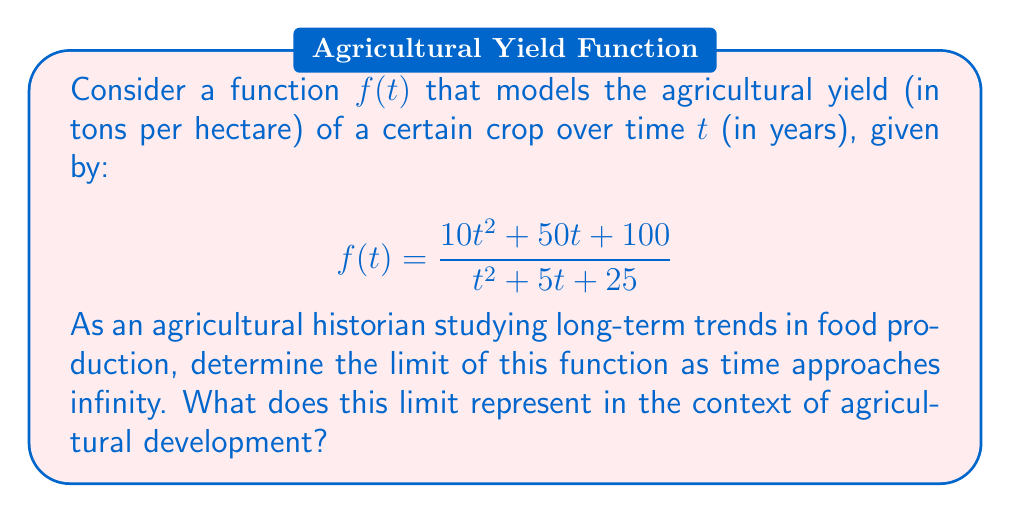Can you solve this math problem? To solve this problem, we'll follow these steps:

1) To find the limit as $t$ approaches infinity, we need to look at the behavior of the numerator and denominator separately as $t$ gets very large.

2) Both the numerator and denominator are quadratic functions. When $t$ is very large, the $t^2$ term will dominate in both.

3) We can factor out $t^2$ from both the numerator and denominator:

   $$\lim_{t \to \infty} f(t) = \lim_{t \to \infty} \frac{t^2(10 + \frac{50}{t} + \frac{100}{t^2})}{t^2(1 + \frac{5}{t} + \frac{25}{t^2})}$$

4) As $t$ approaches infinity, $\frac{1}{t}$ and $\frac{1}{t^2}$ approach 0, so:

   $$\lim_{t \to \infty} f(t) = \lim_{t \to \infty} \frac{t^2(10 + 0 + 0)}{t^2(1 + 0 + 0)} = \frac{10t^2}{t^2} = 10$$

5) Therefore, the limit of the function as $t$ approaches infinity is 10.

In the context of agricultural development, this limit represents the maximum theoretical yield (in tons per hectare) that can be achieved for this crop as time goes on and agricultural practices continue to improve. It suggests that despite continuous advancements in farming techniques, there is an upper bound to how much the yield can increase, likely due to biological limitations of the crop or fundamental constraints in the agricultural system.
Answer: The limit of the function as $t$ approaches infinity is 10 tons per hectare. 